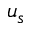<formula> <loc_0><loc_0><loc_500><loc_500>u _ { s }</formula> 